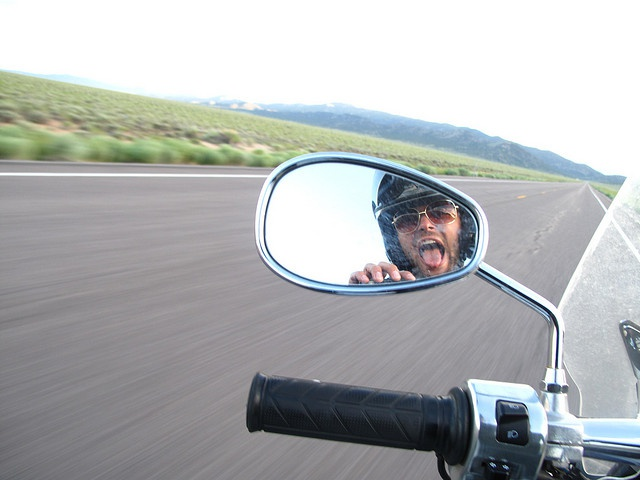Describe the objects in this image and their specific colors. I can see motorcycle in white, black, darkgray, and gray tones and people in white, gray, black, and lightpink tones in this image. 